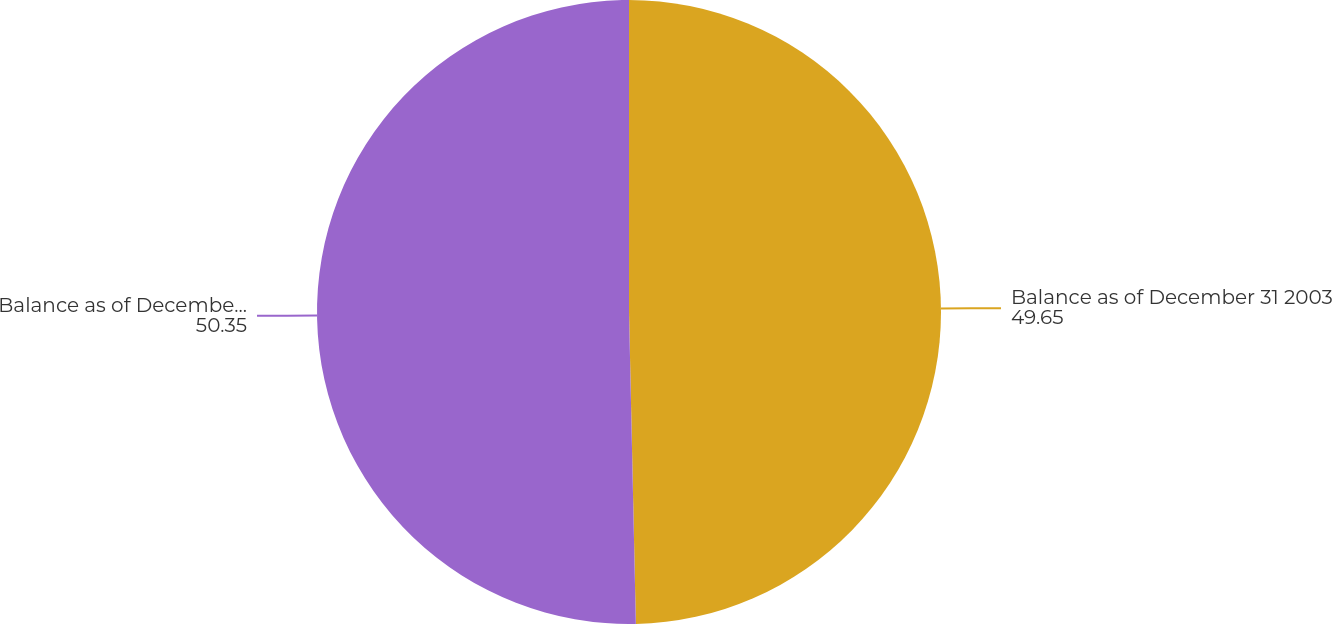Convert chart to OTSL. <chart><loc_0><loc_0><loc_500><loc_500><pie_chart><fcel>Balance as of December 31 2003<fcel>Balance as of December 31 2004<nl><fcel>49.65%<fcel>50.35%<nl></chart> 